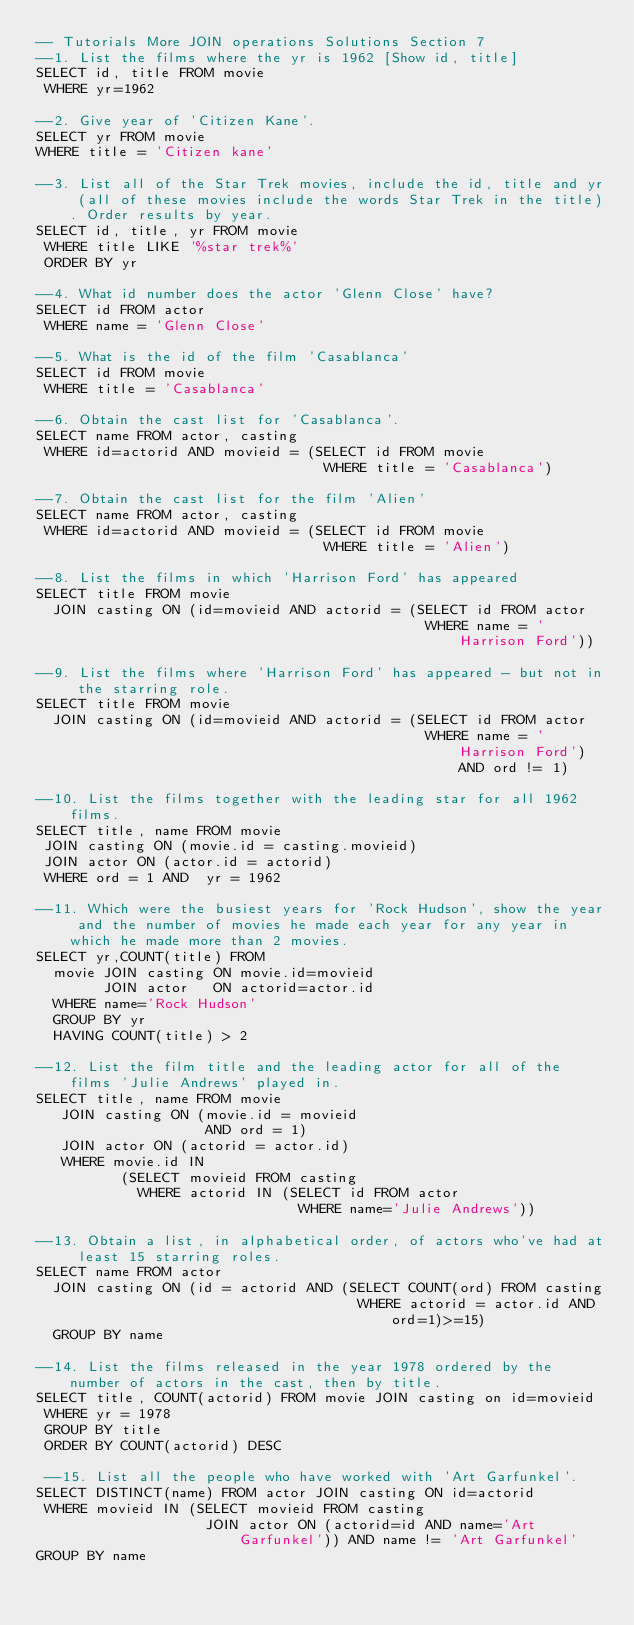Convert code to text. <code><loc_0><loc_0><loc_500><loc_500><_SQL_>-- Tutorials More JOIN operations Solutions Section 7
--1. List the films where the yr is 1962 [Show id, title]
SELECT id, title FROM movie
 WHERE yr=1962

--2. Give year of 'Citizen Kane'.
SELECT yr FROM movie
WHERE title = 'Citizen kane'

--3. List all of the Star Trek movies, include the id, title and yr (all of these movies include the words Star Trek in the title). Order results by year.
SELECT id, title, yr FROM movie
 WHERE title LIKE '%star trek%'
 ORDER BY yr

--4. What id number does the actor 'Glenn Close' have?
SELECT id FROM actor
 WHERE name = 'Glenn Close'

--5. What is the id of the film 'Casablanca'
SELECT id FROM movie
 WHERE title = 'Casablanca'

--6. Obtain the cast list for 'Casablanca'.
SELECT name FROM actor, casting
 WHERE id=actorid AND movieid = (SELECT id FROM movie 
                                  WHERE title = 'Casablanca')

--7. Obtain the cast list for the film 'Alien'
SELECT name FROM actor, casting
 WHERE id=actorid AND movieid = (SELECT id FROM movie 
                                  WHERE title = 'Alien')

--8. List the films in which 'Harrison Ford' has appeared
SELECT title FROM movie
  JOIN casting ON (id=movieid AND actorid = (SELECT id FROM actor 
                                              WHERE name = 'Harrison Ford'))

--9. List the films where 'Harrison Ford' has appeared - but not in the starring role.
SELECT title FROM movie
  JOIN casting ON (id=movieid AND actorid = (SELECT id FROM actor 
                                              WHERE name = 'Harrison Ford') AND ord != 1)

--10. List the films together with the leading star for all 1962 films.
SELECT title, name FROM movie
 JOIN casting ON (movie.id = casting.movieid)
 JOIN actor ON (actor.id = actorid)
 WHERE ord = 1 AND  yr = 1962

--11. Which were the busiest years for 'Rock Hudson', show the year and the number of movies he made each year for any year in which he made more than 2 movies.
SELECT yr,COUNT(title) FROM
  movie JOIN casting ON movie.id=movieid
        JOIN actor   ON actorid=actor.id
  WHERE name='Rock Hudson'
  GROUP BY yr
  HAVING COUNT(title) > 2

--12. List the film title and the leading actor for all of the films 'Julie Andrews' played in.
SELECT title, name FROM movie
   JOIN casting ON (movie.id = movieid
                    AND ord = 1)
   JOIN actor ON (actorid = actor.id)
   WHERE movie.id IN
          (SELECT movieid FROM casting 
            WHERE actorid IN (SELECT id FROM actor
                               WHERE name='Julie Andrews'))

--13. Obtain a list, in alphabetical order, of actors who've had at least 15 starring roles.
SELECT name FROM actor
  JOIN casting ON (id = actorid AND (SELECT COUNT(ord) FROM casting 
                                      WHERE actorid = actor.id AND ord=1)>=15)
  GROUP BY name

--14. List the films released in the year 1978 ordered by the number of actors in the cast, then by title.
SELECT title, COUNT(actorid) FROM movie JOIN casting on id=movieid
 WHERE yr = 1978
 GROUP BY title 
 ORDER BY COUNT(actorid) DESC

 --15. List all the people who have worked with 'Art Garfunkel'.
SELECT DISTINCT(name) FROM actor JOIN casting ON id=actorid
 WHERE movieid IN (SELECT movieid FROM casting 
                    JOIN actor ON (actorid=id AND name='Art Garfunkel')) AND name != 'Art Garfunkel'
GROUP BY name 
</code> 